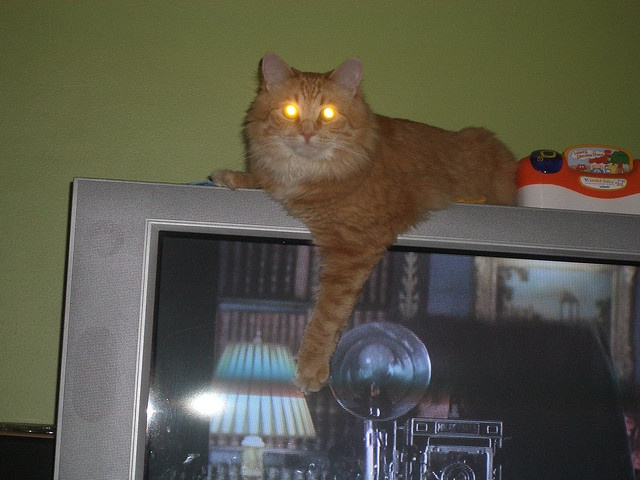Describe the objects in this image and their specific colors. I can see tv in darkgreen, gray, and black tones and cat in darkgreen, maroon, and gray tones in this image. 